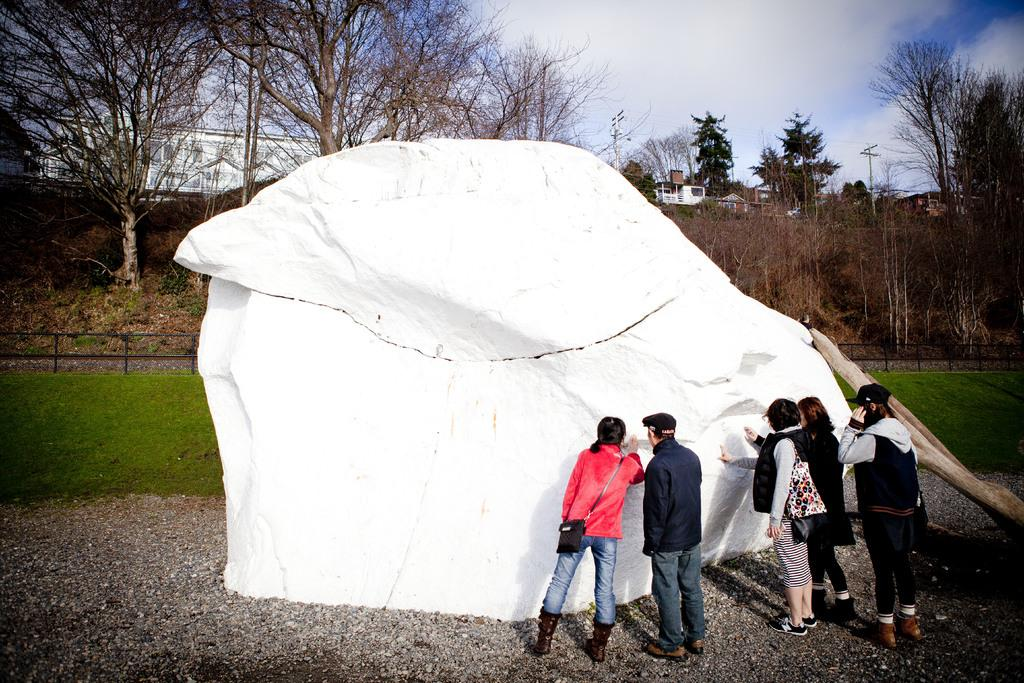What are the people standing near in the image? The people are standing near a white stone. What can be seen in the background of the image? There is grass, fencing, trees, buildings, and the sky visible in the background of the image. What sense does the tree in the image possess? There is no tree present in the image, so it is not possible to determine what sense it might possess. 